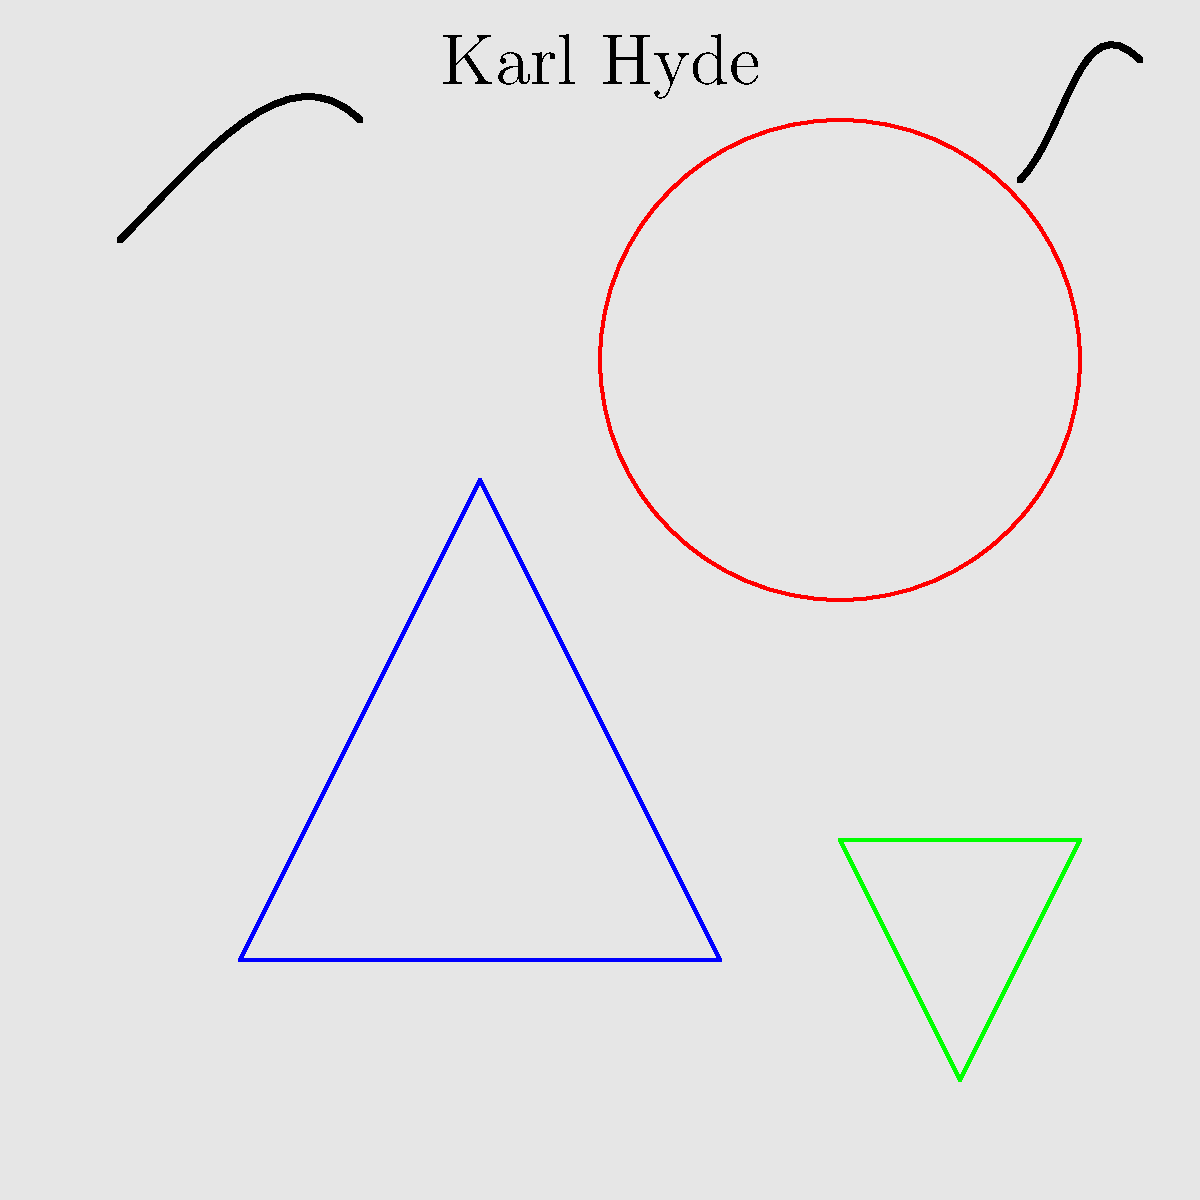Based on the visual representation above, which of Karl Hyde's artistic collaborations does this installation most likely represent? To answer this question, let's analyze the key elements in the image:

1. The overall structure represents an art installation, indicating a visual arts project.
2. Karl Hyde's name is prominently displayed, confirming his involvement.
3. The presence of abstract shapes (blue triangle, red circle, green triangle) suggests a visual art component.
4. The musical notes imply a connection to Hyde's musical background.
5. The combination of visual art and musical elements points to a multimedia collaboration.

Given these elements, the installation most likely represents "Someday World," a collaborative project between Karl Hyde and Brian Eno. This project, released in 2014, combined music with visual art installations, perfectly matching the elements in the image:

- The abstract shapes represent the visual art component of the project.
- The musical notes symbolize the album they created together.
- The installation-like structure reflects the exhibition spaces where their collaborative work was displayed.

Karl Hyde and Brian Eno's "Someday World" project was known for blending music, visual art, and immersive installations, making it the most fitting answer based on the visual evidence provided.
Answer: Someday World 